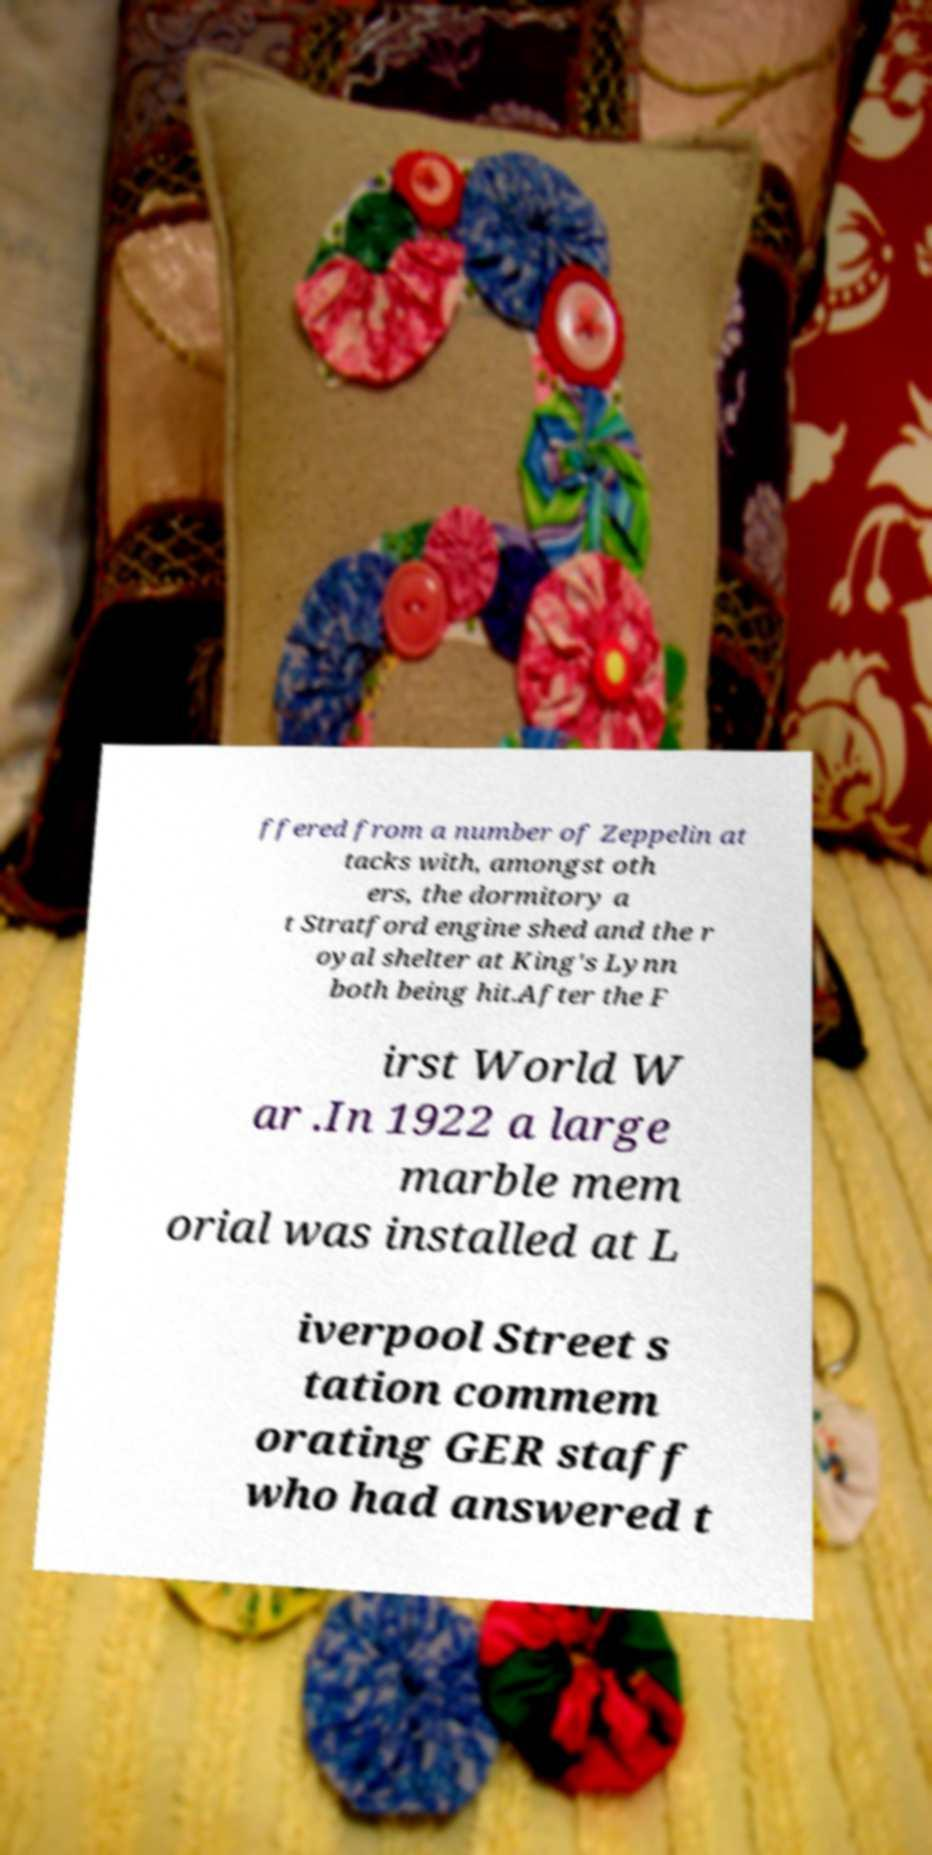Could you extract and type out the text from this image? ffered from a number of Zeppelin at tacks with, amongst oth ers, the dormitory a t Stratford engine shed and the r oyal shelter at King's Lynn both being hit.After the F irst World W ar .In 1922 a large marble mem orial was installed at L iverpool Street s tation commem orating GER staff who had answered t 